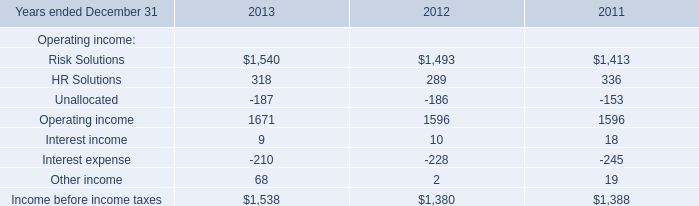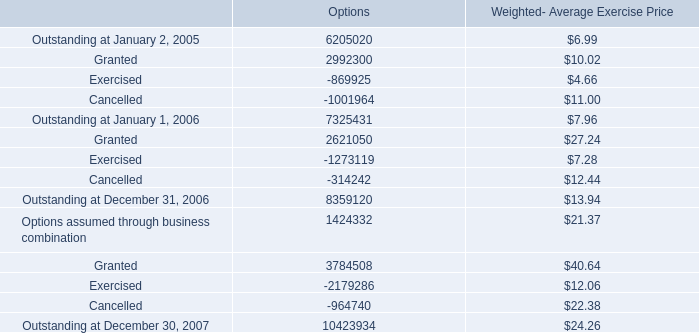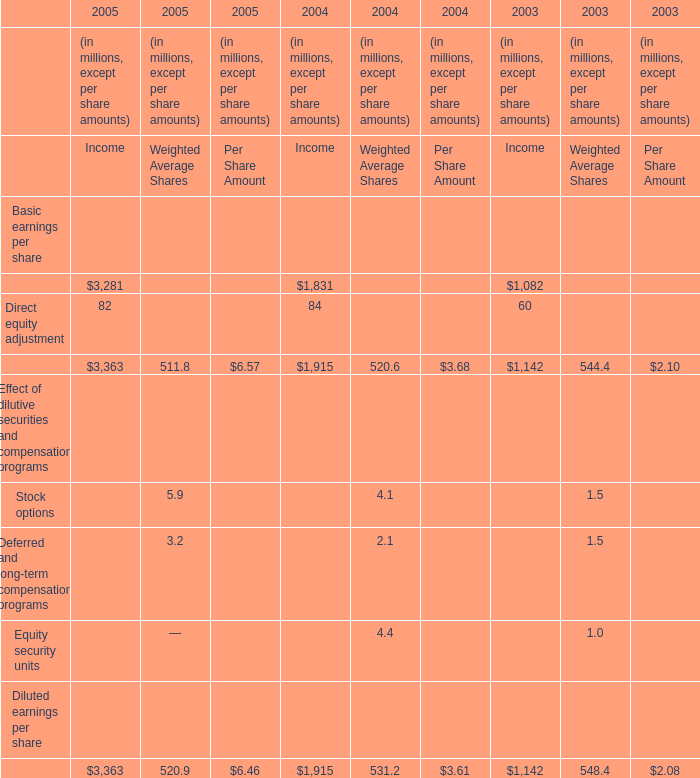what's the total amount of Risk Solutions of 2012, Outstanding at December 31, 2006 of Options, and Cancelled of Options ? 
Computations: ((1493.0 + 8359120.0) + 314242.0)
Answer: 8674855.0. 